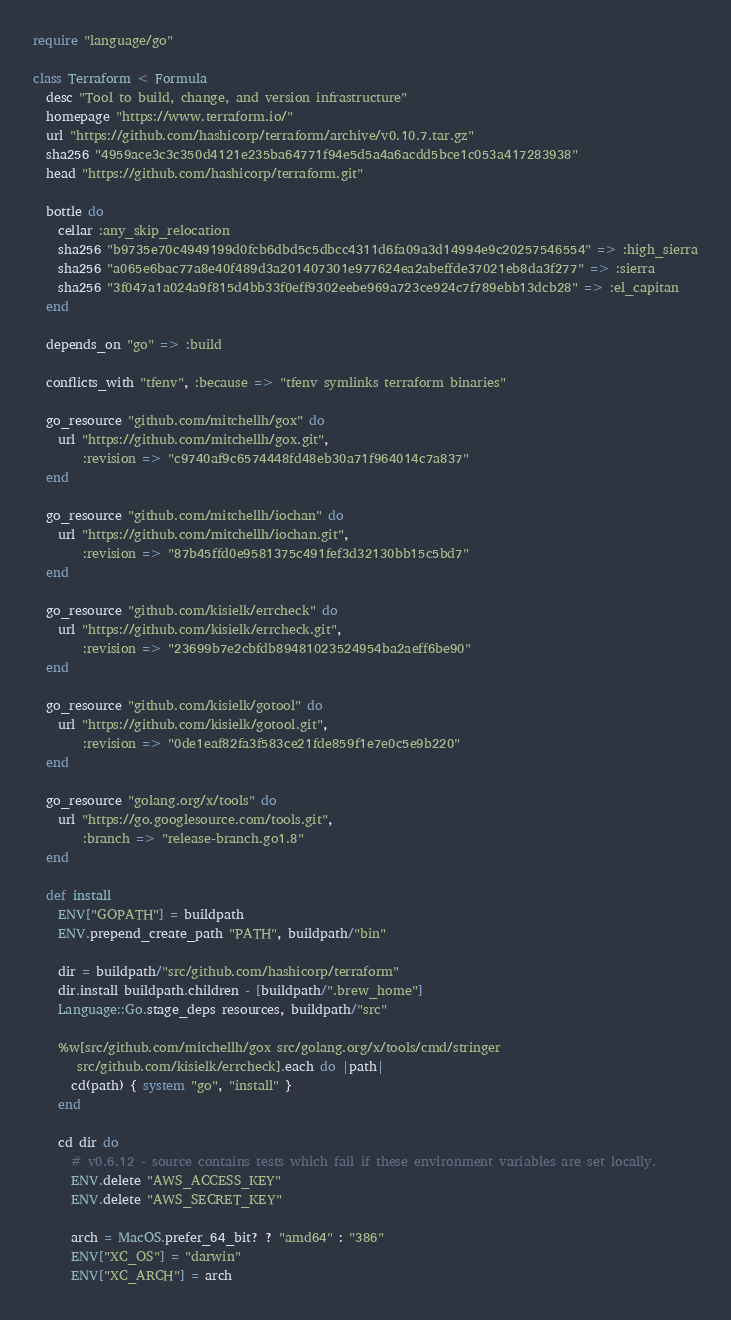Convert code to text. <code><loc_0><loc_0><loc_500><loc_500><_Ruby_>require "language/go"

class Terraform < Formula
  desc "Tool to build, change, and version infrastructure"
  homepage "https://www.terraform.io/"
  url "https://github.com/hashicorp/terraform/archive/v0.10.7.tar.gz"
  sha256 "4959ace3c3c350d4121e235ba64771f94e5d5a4a6acdd5bce1c053a417283938"
  head "https://github.com/hashicorp/terraform.git"

  bottle do
    cellar :any_skip_relocation
    sha256 "b9735e70c4949199d0fcb6dbd5c5dbcc4311d6fa09a3d14994e9c20257546554" => :high_sierra
    sha256 "a065e6bac77a8e40f489d3a201407301e977624ea2abeffde37021eb8da3f277" => :sierra
    sha256 "3f047a1a024a9f815d4bb33f0eff9302eebe969a723ce924c7f789ebb13dcb28" => :el_capitan
  end

  depends_on "go" => :build

  conflicts_with "tfenv", :because => "tfenv symlinks terraform binaries"

  go_resource "github.com/mitchellh/gox" do
    url "https://github.com/mitchellh/gox.git",
        :revision => "c9740af9c6574448fd48eb30a71f964014c7a837"
  end

  go_resource "github.com/mitchellh/iochan" do
    url "https://github.com/mitchellh/iochan.git",
        :revision => "87b45ffd0e9581375c491fef3d32130bb15c5bd7"
  end

  go_resource "github.com/kisielk/errcheck" do
    url "https://github.com/kisielk/errcheck.git",
        :revision => "23699b7e2cbfdb89481023524954ba2aeff6be90"
  end

  go_resource "github.com/kisielk/gotool" do
    url "https://github.com/kisielk/gotool.git",
        :revision => "0de1eaf82fa3f583ce21fde859f1e7e0c5e9b220"
  end

  go_resource "golang.org/x/tools" do
    url "https://go.googlesource.com/tools.git",
        :branch => "release-branch.go1.8"
  end

  def install
    ENV["GOPATH"] = buildpath
    ENV.prepend_create_path "PATH", buildpath/"bin"

    dir = buildpath/"src/github.com/hashicorp/terraform"
    dir.install buildpath.children - [buildpath/".brew_home"]
    Language::Go.stage_deps resources, buildpath/"src"

    %w[src/github.com/mitchellh/gox src/golang.org/x/tools/cmd/stringer
       src/github.com/kisielk/errcheck].each do |path|
      cd(path) { system "go", "install" }
    end

    cd dir do
      # v0.6.12 - source contains tests which fail if these environment variables are set locally.
      ENV.delete "AWS_ACCESS_KEY"
      ENV.delete "AWS_SECRET_KEY"

      arch = MacOS.prefer_64_bit? ? "amd64" : "386"
      ENV["XC_OS"] = "darwin"
      ENV["XC_ARCH"] = arch</code> 